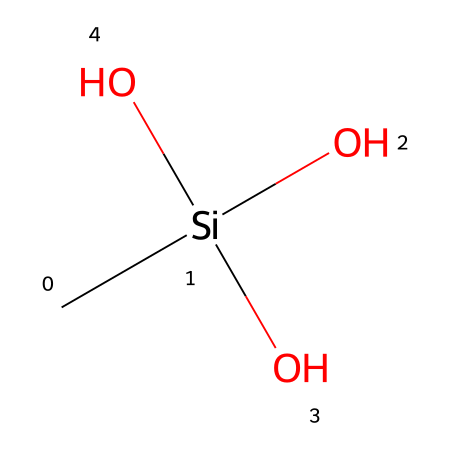What is the total number of oxygen atoms in methylsilanetriol? The chemical structure shows three hydroxyl (OH) groups attached to the silicon atom, each contributing one oxygen atom. Counting the oxygen atoms gives a total of three.
Answer: three How many hydrogen atoms are present in methylsilanetriol? There is one methyl group (CH3) contributing three hydrogen atoms, and three hydroxyl groups each contribute one hydrogen atom. Adding these together gives a total of six hydrogen atoms.
Answer: six What type of bonding is predominantly found in methylsilanetriol? The chemical structure features covalent bonds between the silicon atom and both the carbon and oxygen atoms. These bonds are the primary means by which the atoms are held together in this compound.
Answer: covalent bonding How many total atoms are there in methylsilanetriol? The structure consists of one silicon atom, one carbon atom, three oxygen atoms, and six hydrogen atoms. Adding these up leads to a total of eleven atoms in the molecule.
Answer: eleven What is the hybridization of the silicon atom in methylsilanetriol? The silicon atom forms four bonds: one with a carbon atom and three with hydroxyl groups. This hybridization involves four equivalent sp3 hybrid orbitals, indicating a tetrahedral geometry around silicon.
Answer: sp3 Which functional groups are present in methylsilanetriol? The presence of the hydroxyl groups (OH) in the structure indicates alcohol functional groups. The combination of these groups with the silicon also classifies the compound within organosilicon chemistry.
Answer: alcohols What is the significance of methylsilanetriol in joint health supplements? Methylsilanetriol is notable for its bioavailability, meaning it can be readily absorbed and utilized by the body, particularly contributing to the health of joints and connective tissues due to its silicon content.
Answer: bioavailability 